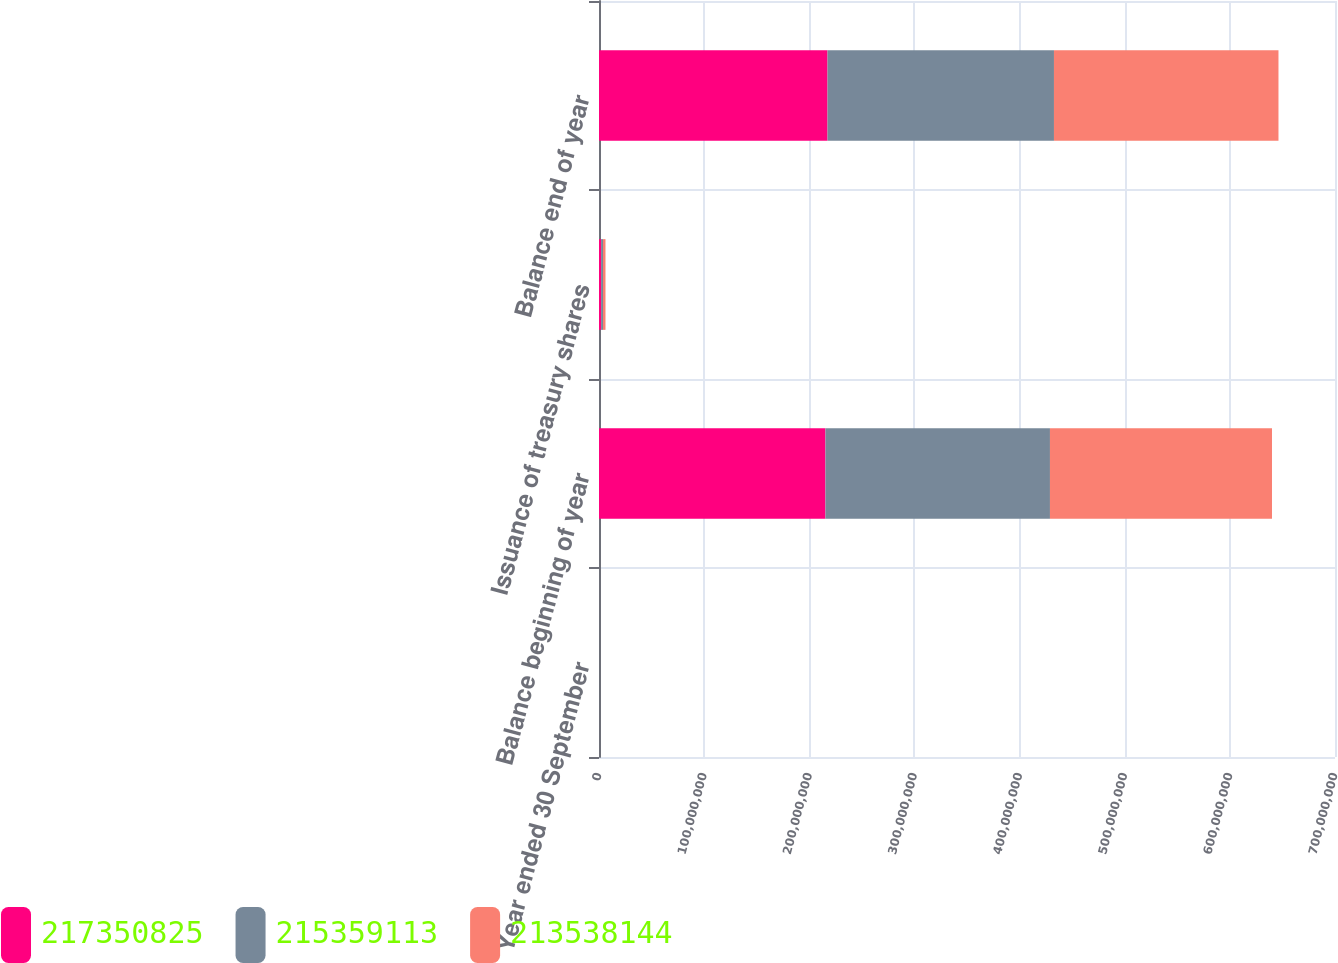<chart> <loc_0><loc_0><loc_500><loc_500><stacked_bar_chart><ecel><fcel>Year ended 30 September<fcel>Balance beginning of year<fcel>Issuance of treasury shares<fcel>Balance end of year<nl><fcel>2.17351e+08<fcel>2016<fcel>2.15359e+08<fcel>1.99171e+06<fcel>2.17351e+08<nl><fcel>2.15359e+08<fcel>2015<fcel>2.13538e+08<fcel>1.82097e+06<fcel>2.15359e+08<nl><fcel>2.13538e+08<fcel>2014<fcel>2.11179e+08<fcel>2.35889e+06<fcel>2.13538e+08<nl></chart> 